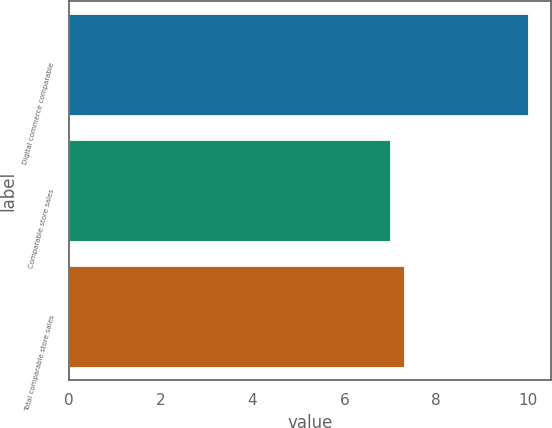Convert chart to OTSL. <chart><loc_0><loc_0><loc_500><loc_500><bar_chart><fcel>Digital commerce comparable<fcel>Comparable store sales<fcel>Total comparable store sales<nl><fcel>10<fcel>7<fcel>7.3<nl></chart> 